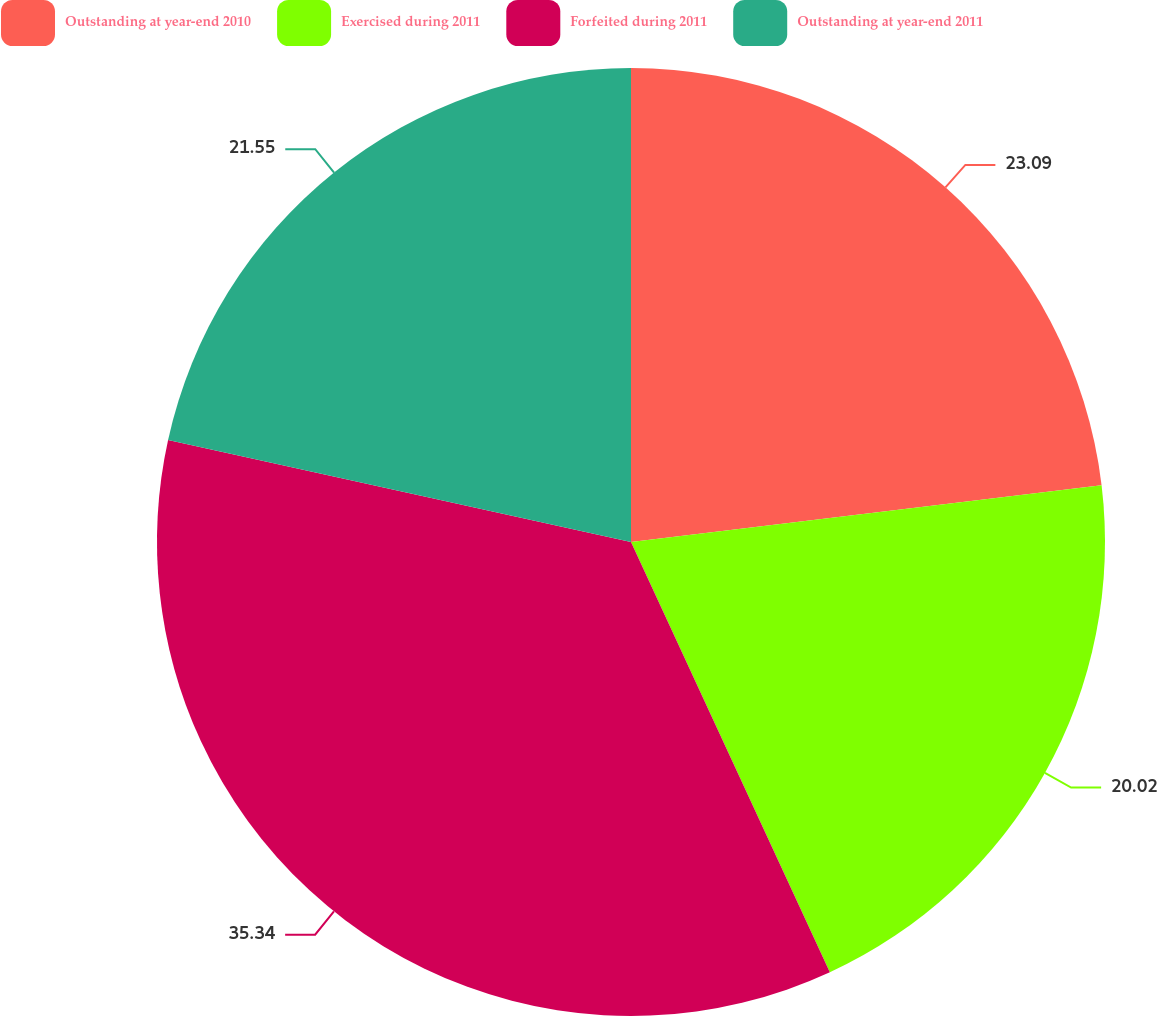<chart> <loc_0><loc_0><loc_500><loc_500><pie_chart><fcel>Outstanding at year-end 2010<fcel>Exercised during 2011<fcel>Forfeited during 2011<fcel>Outstanding at year-end 2011<nl><fcel>23.09%<fcel>20.02%<fcel>35.34%<fcel>21.55%<nl></chart> 